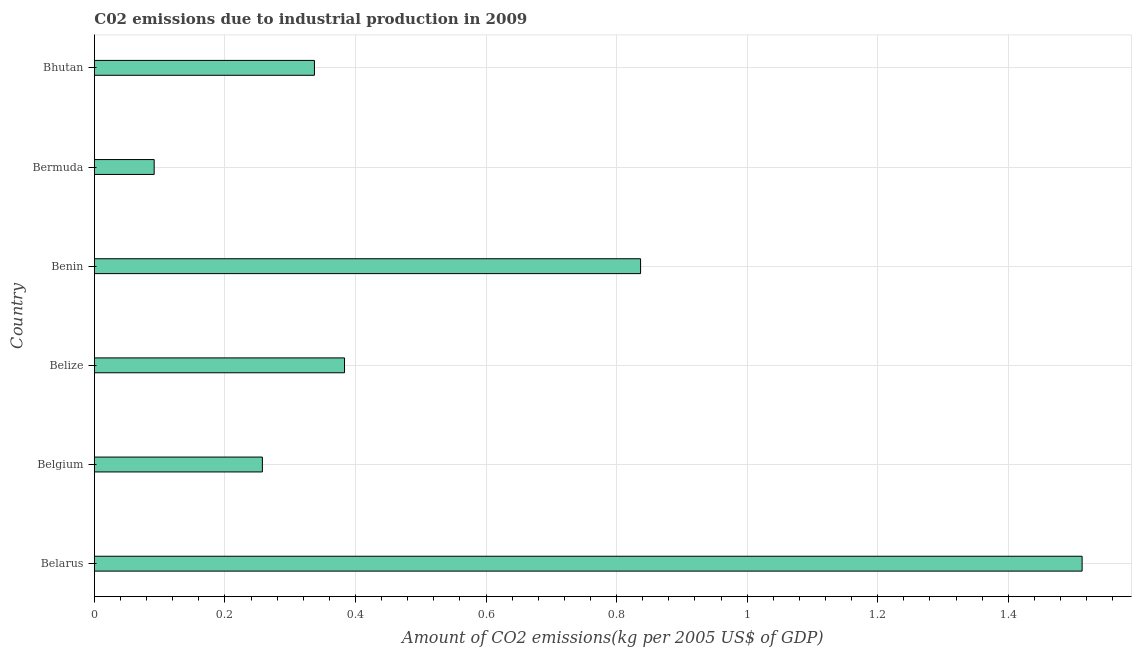Does the graph contain any zero values?
Provide a succinct answer. No. What is the title of the graph?
Your response must be concise. C02 emissions due to industrial production in 2009. What is the label or title of the X-axis?
Your response must be concise. Amount of CO2 emissions(kg per 2005 US$ of GDP). What is the amount of co2 emissions in Belgium?
Your response must be concise. 0.26. Across all countries, what is the maximum amount of co2 emissions?
Give a very brief answer. 1.51. Across all countries, what is the minimum amount of co2 emissions?
Your answer should be very brief. 0.09. In which country was the amount of co2 emissions maximum?
Provide a succinct answer. Belarus. In which country was the amount of co2 emissions minimum?
Make the answer very short. Bermuda. What is the sum of the amount of co2 emissions?
Provide a succinct answer. 3.42. What is the difference between the amount of co2 emissions in Belarus and Belgium?
Provide a short and direct response. 1.26. What is the average amount of co2 emissions per country?
Make the answer very short. 0.57. What is the median amount of co2 emissions?
Offer a very short reply. 0.36. What is the ratio of the amount of co2 emissions in Benin to that in Bermuda?
Give a very brief answer. 9.13. What is the difference between the highest and the second highest amount of co2 emissions?
Keep it short and to the point. 0.68. Is the sum of the amount of co2 emissions in Belgium and Bermuda greater than the maximum amount of co2 emissions across all countries?
Your response must be concise. No. What is the difference between the highest and the lowest amount of co2 emissions?
Give a very brief answer. 1.42. How many bars are there?
Keep it short and to the point. 6. Are the values on the major ticks of X-axis written in scientific E-notation?
Make the answer very short. No. What is the Amount of CO2 emissions(kg per 2005 US$ of GDP) of Belarus?
Provide a succinct answer. 1.51. What is the Amount of CO2 emissions(kg per 2005 US$ of GDP) of Belgium?
Ensure brevity in your answer.  0.26. What is the Amount of CO2 emissions(kg per 2005 US$ of GDP) of Belize?
Offer a terse response. 0.38. What is the Amount of CO2 emissions(kg per 2005 US$ of GDP) in Benin?
Your answer should be compact. 0.84. What is the Amount of CO2 emissions(kg per 2005 US$ of GDP) of Bermuda?
Your answer should be compact. 0.09. What is the Amount of CO2 emissions(kg per 2005 US$ of GDP) of Bhutan?
Offer a terse response. 0.34. What is the difference between the Amount of CO2 emissions(kg per 2005 US$ of GDP) in Belarus and Belgium?
Provide a short and direct response. 1.26. What is the difference between the Amount of CO2 emissions(kg per 2005 US$ of GDP) in Belarus and Belize?
Make the answer very short. 1.13. What is the difference between the Amount of CO2 emissions(kg per 2005 US$ of GDP) in Belarus and Benin?
Provide a succinct answer. 0.68. What is the difference between the Amount of CO2 emissions(kg per 2005 US$ of GDP) in Belarus and Bermuda?
Provide a succinct answer. 1.42. What is the difference between the Amount of CO2 emissions(kg per 2005 US$ of GDP) in Belarus and Bhutan?
Provide a succinct answer. 1.18. What is the difference between the Amount of CO2 emissions(kg per 2005 US$ of GDP) in Belgium and Belize?
Give a very brief answer. -0.13. What is the difference between the Amount of CO2 emissions(kg per 2005 US$ of GDP) in Belgium and Benin?
Your response must be concise. -0.58. What is the difference between the Amount of CO2 emissions(kg per 2005 US$ of GDP) in Belgium and Bermuda?
Offer a terse response. 0.17. What is the difference between the Amount of CO2 emissions(kg per 2005 US$ of GDP) in Belgium and Bhutan?
Provide a short and direct response. -0.08. What is the difference between the Amount of CO2 emissions(kg per 2005 US$ of GDP) in Belize and Benin?
Ensure brevity in your answer.  -0.45. What is the difference between the Amount of CO2 emissions(kg per 2005 US$ of GDP) in Belize and Bermuda?
Keep it short and to the point. 0.29. What is the difference between the Amount of CO2 emissions(kg per 2005 US$ of GDP) in Belize and Bhutan?
Provide a succinct answer. 0.05. What is the difference between the Amount of CO2 emissions(kg per 2005 US$ of GDP) in Benin and Bermuda?
Your answer should be compact. 0.75. What is the difference between the Amount of CO2 emissions(kg per 2005 US$ of GDP) in Benin and Bhutan?
Your answer should be compact. 0.5. What is the difference between the Amount of CO2 emissions(kg per 2005 US$ of GDP) in Bermuda and Bhutan?
Your answer should be compact. -0.25. What is the ratio of the Amount of CO2 emissions(kg per 2005 US$ of GDP) in Belarus to that in Belgium?
Your answer should be very brief. 5.88. What is the ratio of the Amount of CO2 emissions(kg per 2005 US$ of GDP) in Belarus to that in Belize?
Make the answer very short. 3.95. What is the ratio of the Amount of CO2 emissions(kg per 2005 US$ of GDP) in Belarus to that in Benin?
Your response must be concise. 1.81. What is the ratio of the Amount of CO2 emissions(kg per 2005 US$ of GDP) in Belarus to that in Bermuda?
Keep it short and to the point. 16.51. What is the ratio of the Amount of CO2 emissions(kg per 2005 US$ of GDP) in Belarus to that in Bhutan?
Your answer should be compact. 4.49. What is the ratio of the Amount of CO2 emissions(kg per 2005 US$ of GDP) in Belgium to that in Belize?
Ensure brevity in your answer.  0.67. What is the ratio of the Amount of CO2 emissions(kg per 2005 US$ of GDP) in Belgium to that in Benin?
Provide a succinct answer. 0.31. What is the ratio of the Amount of CO2 emissions(kg per 2005 US$ of GDP) in Belgium to that in Bermuda?
Your answer should be very brief. 2.81. What is the ratio of the Amount of CO2 emissions(kg per 2005 US$ of GDP) in Belgium to that in Bhutan?
Give a very brief answer. 0.76. What is the ratio of the Amount of CO2 emissions(kg per 2005 US$ of GDP) in Belize to that in Benin?
Ensure brevity in your answer.  0.46. What is the ratio of the Amount of CO2 emissions(kg per 2005 US$ of GDP) in Belize to that in Bermuda?
Your answer should be compact. 4.18. What is the ratio of the Amount of CO2 emissions(kg per 2005 US$ of GDP) in Belize to that in Bhutan?
Your response must be concise. 1.14. What is the ratio of the Amount of CO2 emissions(kg per 2005 US$ of GDP) in Benin to that in Bermuda?
Offer a very short reply. 9.13. What is the ratio of the Amount of CO2 emissions(kg per 2005 US$ of GDP) in Benin to that in Bhutan?
Ensure brevity in your answer.  2.48. What is the ratio of the Amount of CO2 emissions(kg per 2005 US$ of GDP) in Bermuda to that in Bhutan?
Offer a very short reply. 0.27. 